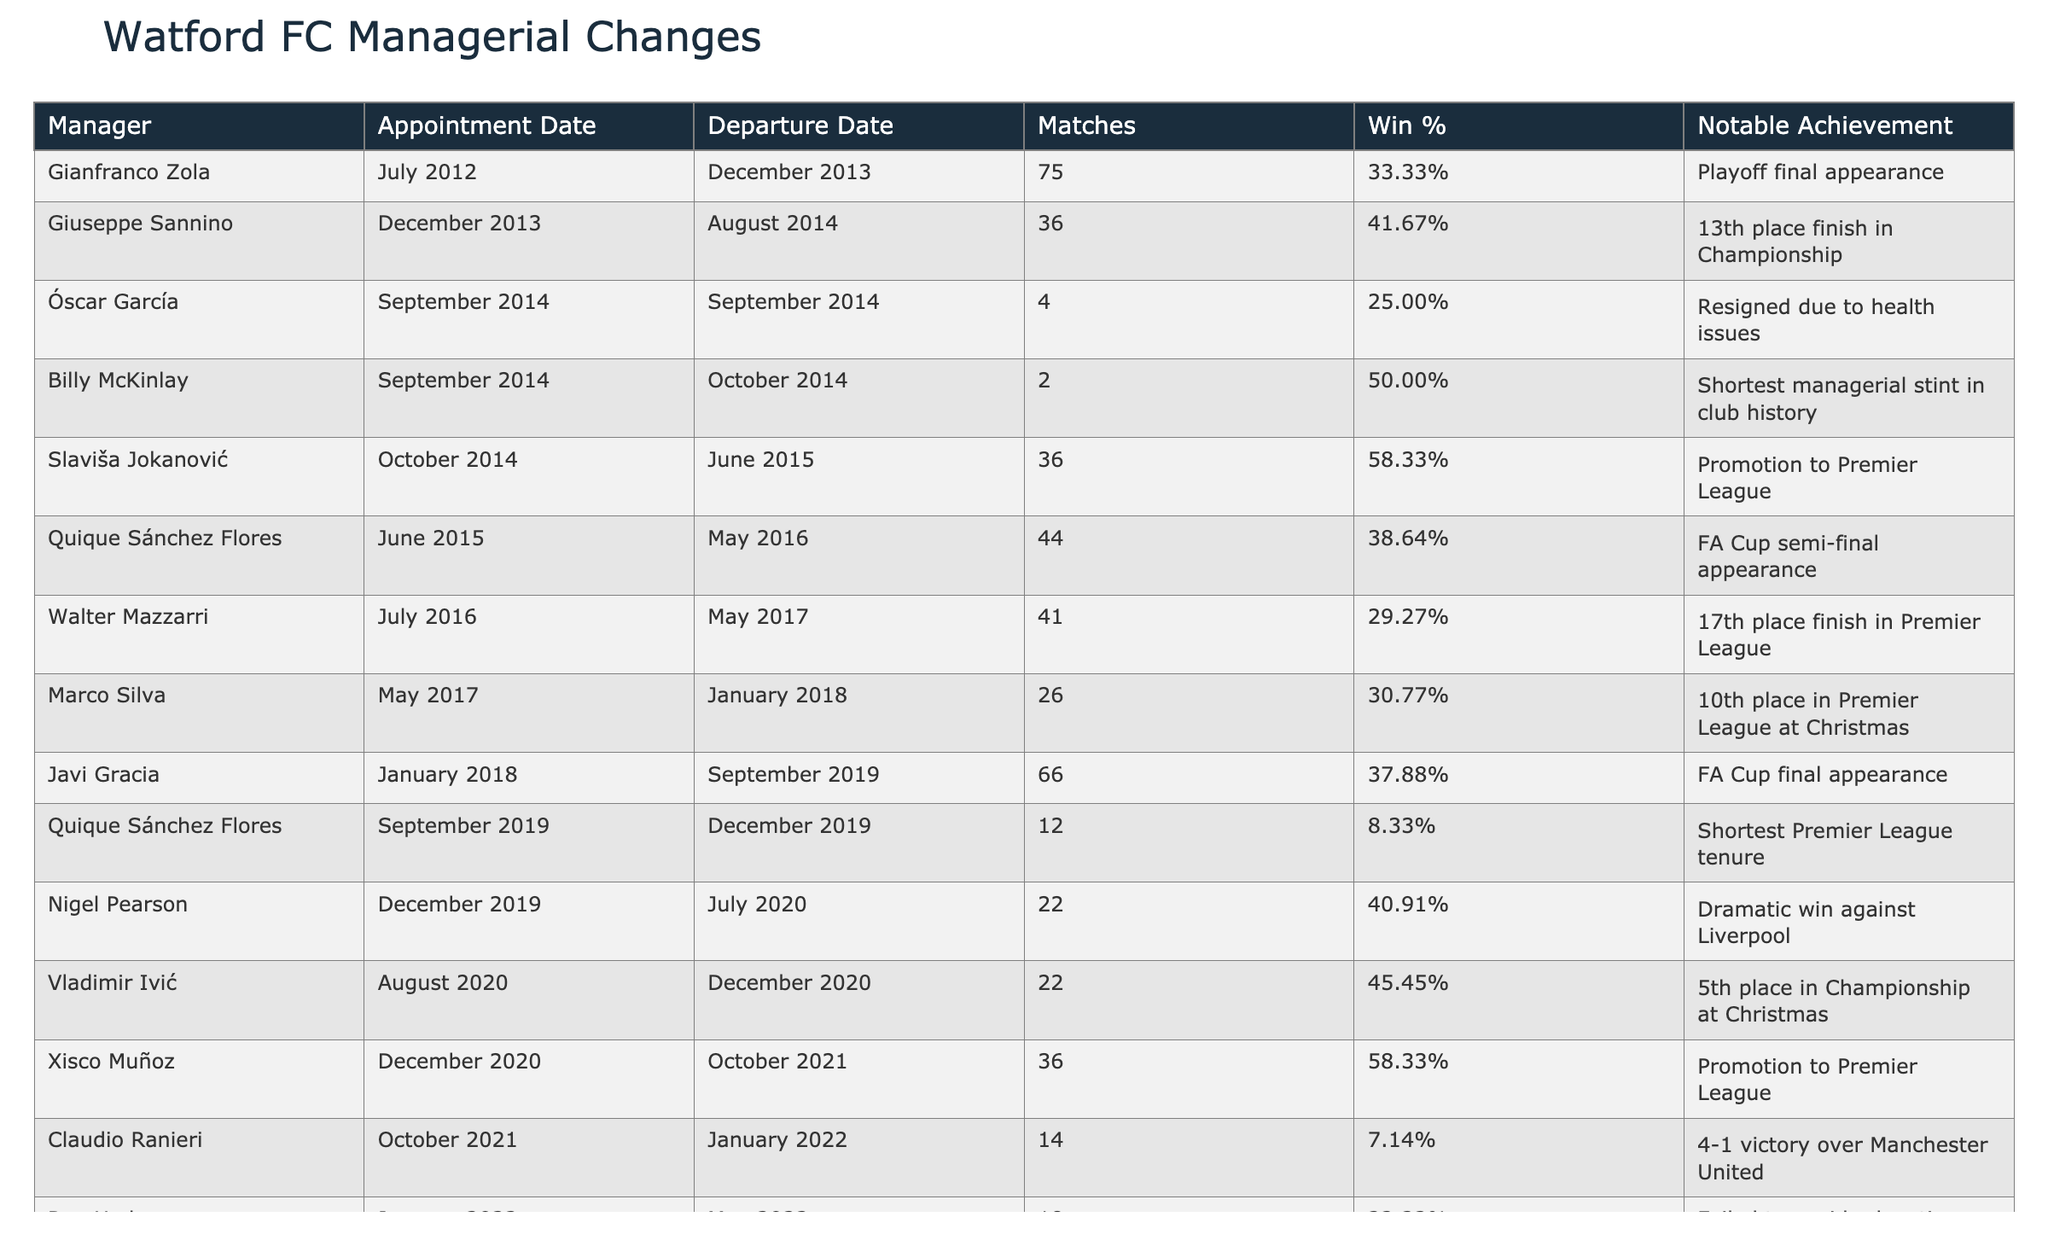What was the appointment date of Slaviša Jokanović? According to the table, Slaviša Jokanović was appointed in October 2014.
Answer: October 2014 How many matches did Claudio Ranieri manage during his tenure? The table indicates that Claudio Ranieri managed 14 matches during his time as head coach at Watford FC.
Answer: 14 Who had the highest win percentage among the managers listed? By reviewing the win percentages in the table, Slaviša Jokanović and Xisco Muñoz both have the highest win percentage at 58.33%.
Answer: Slaviša Jokanović and Xisco Muñoz Did any manager have a win percentage below 10%? By analyzing the table, Quique Sánchez Flores had a win percentage of 8.33%, which is below 10%.
Answer: Yes What is the average number of matches managed by the last three managers? The last three managers were Rob Edwards (11 matches), Slaven Bilić (26 matches), and Chris Wilder (11 matches). Their total matches are 11 + 26 + 11 = 48, and the average is 48 / 3 = 16.
Answer: 16 How many managers achieved promotion to the Premier League? The managers who achieved promotion were Slaviša Jokanović and Xisco Muñoz, as noted in the table. Thus, there were 2 managers who accomplished this.
Answer: 2 What notable achievement did Roy Hodgson have during his tenure? According to the table, Roy Hodgson's notable achievement was failing to avoid relegation.
Answer: Failed to avoid relegation What was the win percentage difference between Marco Silva and Walter Mazzarri? Marco Silva's win percentage was 30.77%, and Walter Mazzarri's was 29.27%. The difference is 30.77% - 29.27% = 1.5%.
Answer: 1.5% 